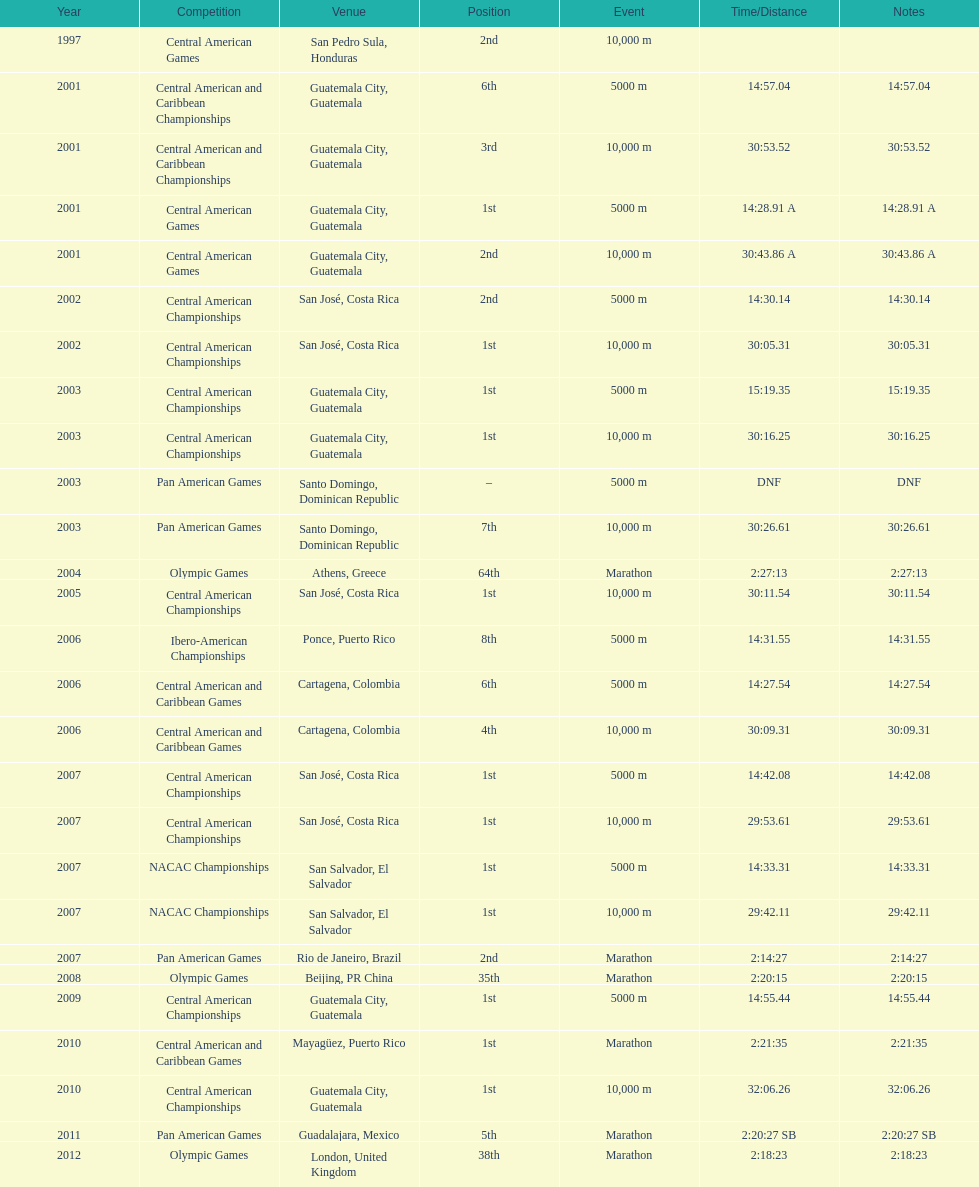Help me parse the entirety of this table. {'header': ['Year', 'Competition', 'Venue', 'Position', 'Event', 'Time/Distance', 'Notes'], 'rows': [['1997', 'Central American Games', 'San Pedro Sula, Honduras', '2nd', '10,000 m', '', ''], ['2001', 'Central American and Caribbean Championships', 'Guatemala City, Guatemala', '6th', '5000 m', '14:57.04', '14:57.04'], ['2001', 'Central American and Caribbean Championships', 'Guatemala City, Guatemala', '3rd', '10,000 m', '30:53.52', '30:53.52'], ['2001', 'Central American Games', 'Guatemala City, Guatemala', '1st', '5000 m', '14:28.91 A', '14:28.91 A'], ['2001', 'Central American Games', 'Guatemala City, Guatemala', '2nd', '10,000 m', '30:43.86 A', '30:43.86 A'], ['2002', 'Central American Championships', 'San José, Costa Rica', '2nd', '5000 m', '14:30.14', '14:30.14'], ['2002', 'Central American Championships', 'San José, Costa Rica', '1st', '10,000 m', '30:05.31', '30:05.31'], ['2003', 'Central American Championships', 'Guatemala City, Guatemala', '1st', '5000 m', '15:19.35', '15:19.35'], ['2003', 'Central American Championships', 'Guatemala City, Guatemala', '1st', '10,000 m', '30:16.25', '30:16.25'], ['2003', 'Pan American Games', 'Santo Domingo, Dominican Republic', '–', '5000 m', 'DNF', 'DNF'], ['2003', 'Pan American Games', 'Santo Domingo, Dominican Republic', '7th', '10,000 m', '30:26.61', '30:26.61'], ['2004', 'Olympic Games', 'Athens, Greece', '64th', 'Marathon', '2:27:13', '2:27:13'], ['2005', 'Central American Championships', 'San José, Costa Rica', '1st', '10,000 m', '30:11.54', '30:11.54'], ['2006', 'Ibero-American Championships', 'Ponce, Puerto Rico', '8th', '5000 m', '14:31.55', '14:31.55'], ['2006', 'Central American and Caribbean Games', 'Cartagena, Colombia', '6th', '5000 m', '14:27.54', '14:27.54'], ['2006', 'Central American and Caribbean Games', 'Cartagena, Colombia', '4th', '10,000 m', '30:09.31', '30:09.31'], ['2007', 'Central American Championships', 'San José, Costa Rica', '1st', '5000 m', '14:42.08', '14:42.08'], ['2007', 'Central American Championships', 'San José, Costa Rica', '1st', '10,000 m', '29:53.61', '29:53.61'], ['2007', 'NACAC Championships', 'San Salvador, El Salvador', '1st', '5000 m', '14:33.31', '14:33.31'], ['2007', 'NACAC Championships', 'San Salvador, El Salvador', '1st', '10,000 m', '29:42.11', '29:42.11'], ['2007', 'Pan American Games', 'Rio de Janeiro, Brazil', '2nd', 'Marathon', '2:14:27', '2:14:27'], ['2008', 'Olympic Games', 'Beijing, PR China', '35th', 'Marathon', '2:20:15', '2:20:15'], ['2009', 'Central American Championships', 'Guatemala City, Guatemala', '1st', '5000 m', '14:55.44', '14:55.44'], ['2010', 'Central American and Caribbean Games', 'Mayagüez, Puerto Rico', '1st', 'Marathon', '2:21:35', '2:21:35'], ['2010', 'Central American Championships', 'Guatemala City, Guatemala', '1st', '10,000 m', '32:06.26', '32:06.26'], ['2011', 'Pan American Games', 'Guadalajara, Mexico', '5th', 'Marathon', '2:20:27 SB', '2:20:27 SB'], ['2012', 'Olympic Games', 'London, United Kingdom', '38th', 'Marathon', '2:18:23', '2:18:23']]} How many times has this athlete not finished in a competition? 1. 